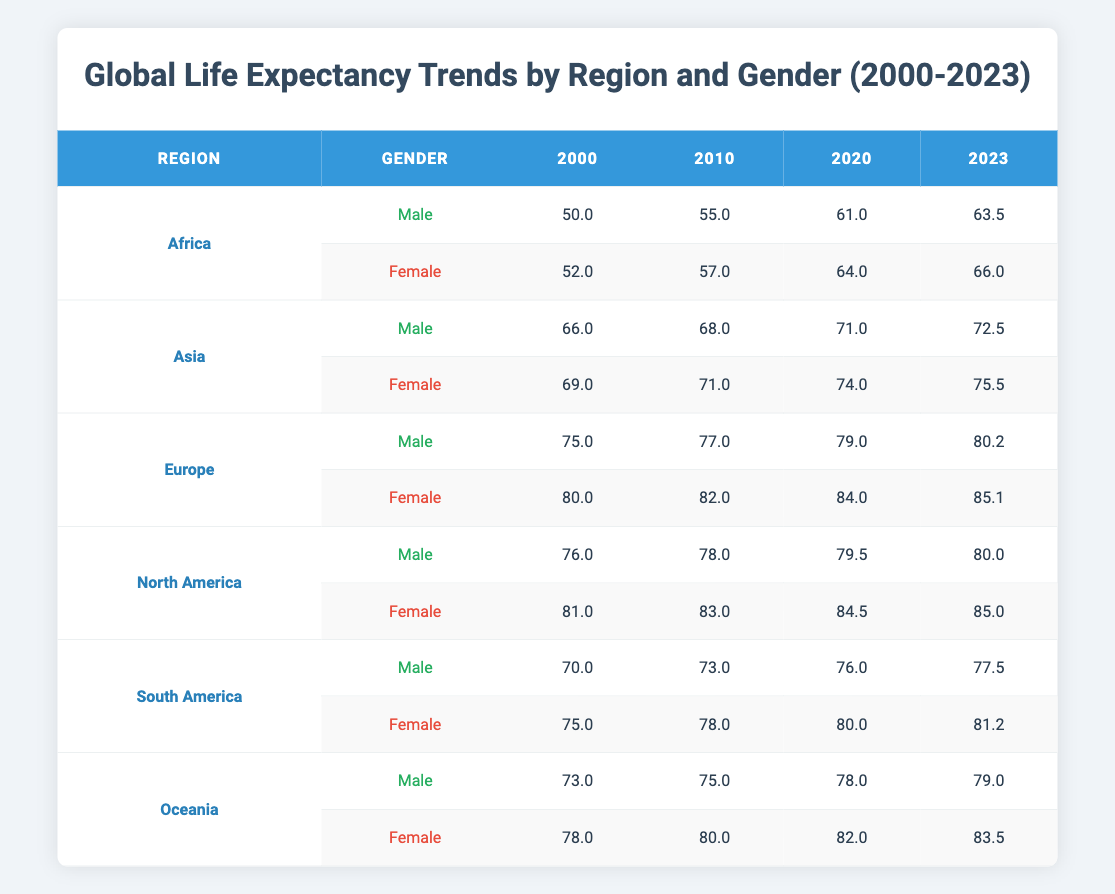What was the life expectancy of females in Africa in 2020? According to the table, the life expectancy of females in Africa in 2020 is directly listed as 64.0 years.
Answer: 64.0 What is the difference in life expectancy between males and females in Europe in 2023? In 2023, the life expectancy of males in Europe is 80.2 years and for females, it is 85.1 years. The difference is calculated as 85.1 - 80.2 = 4.9 years.
Answer: 4.9 Did life expectancy for males in North America decrease between 2010 and 2020? In North America, the life expectancy for males increased from 78.0 in 2010 to 79.5 in 2020. Therefore, the statement is false.
Answer: No What was the average life expectancy of females in Asia from 2000 to 2023? The life expectancies for females in Asia are 69.0 (2000), 71.0 (2010), 74.0 (2020), and 75.5 (2023). The average is (69.0 + 71.0 + 74.0 + 75.5) / 4 = 72.375.
Answer: 72.375 Which region had the highest life expectancy for males in 2020? In 2020, males in Europe had the highest life expectancy at 79.0 years compared to other regions listed in the table.
Answer: Europe What is the percentage increase in life expectancy for females in South America from 2000 to 2023? The life expectancy for females in South America increased from 75.0 in 2000 to 81.2 in 2023. The percentage increase is calculated as ((81.2 - 75.0) / 75.0) * 100 = 8.27%.
Answer: 8.27% Are males in Oceania expected to live longer than males in Africa in 2023? In 2023, the life expectancy for males in Oceania is 79.0 years, while in Africa, it is 63.5 years. Thus, the assertion is true.
Answer: Yes What was the trend in life expectancy for males in Asia from 2000 to 2023? The life expectancy for males in Asia increased consistently from 66.0 in 2000 to 72.5 in 2023, demonstrating an upward trend over the years.
Answer: Increasing 